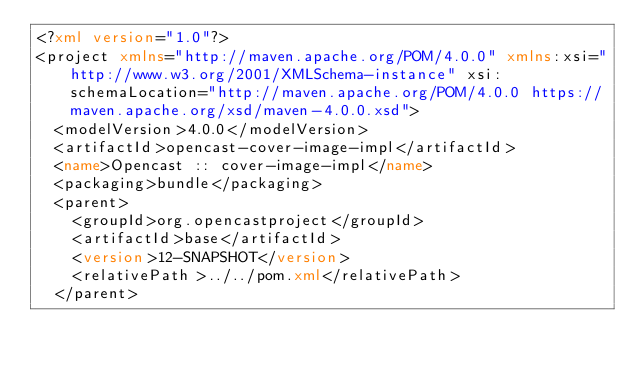<code> <loc_0><loc_0><loc_500><loc_500><_XML_><?xml version="1.0"?>
<project xmlns="http://maven.apache.org/POM/4.0.0" xmlns:xsi="http://www.w3.org/2001/XMLSchema-instance" xsi:schemaLocation="http://maven.apache.org/POM/4.0.0 https://maven.apache.org/xsd/maven-4.0.0.xsd">
  <modelVersion>4.0.0</modelVersion>
  <artifactId>opencast-cover-image-impl</artifactId>
  <name>Opencast :: cover-image-impl</name>
  <packaging>bundle</packaging>
  <parent>
    <groupId>org.opencastproject</groupId>
    <artifactId>base</artifactId>
    <version>12-SNAPSHOT</version>
    <relativePath>../../pom.xml</relativePath>
  </parent></code> 